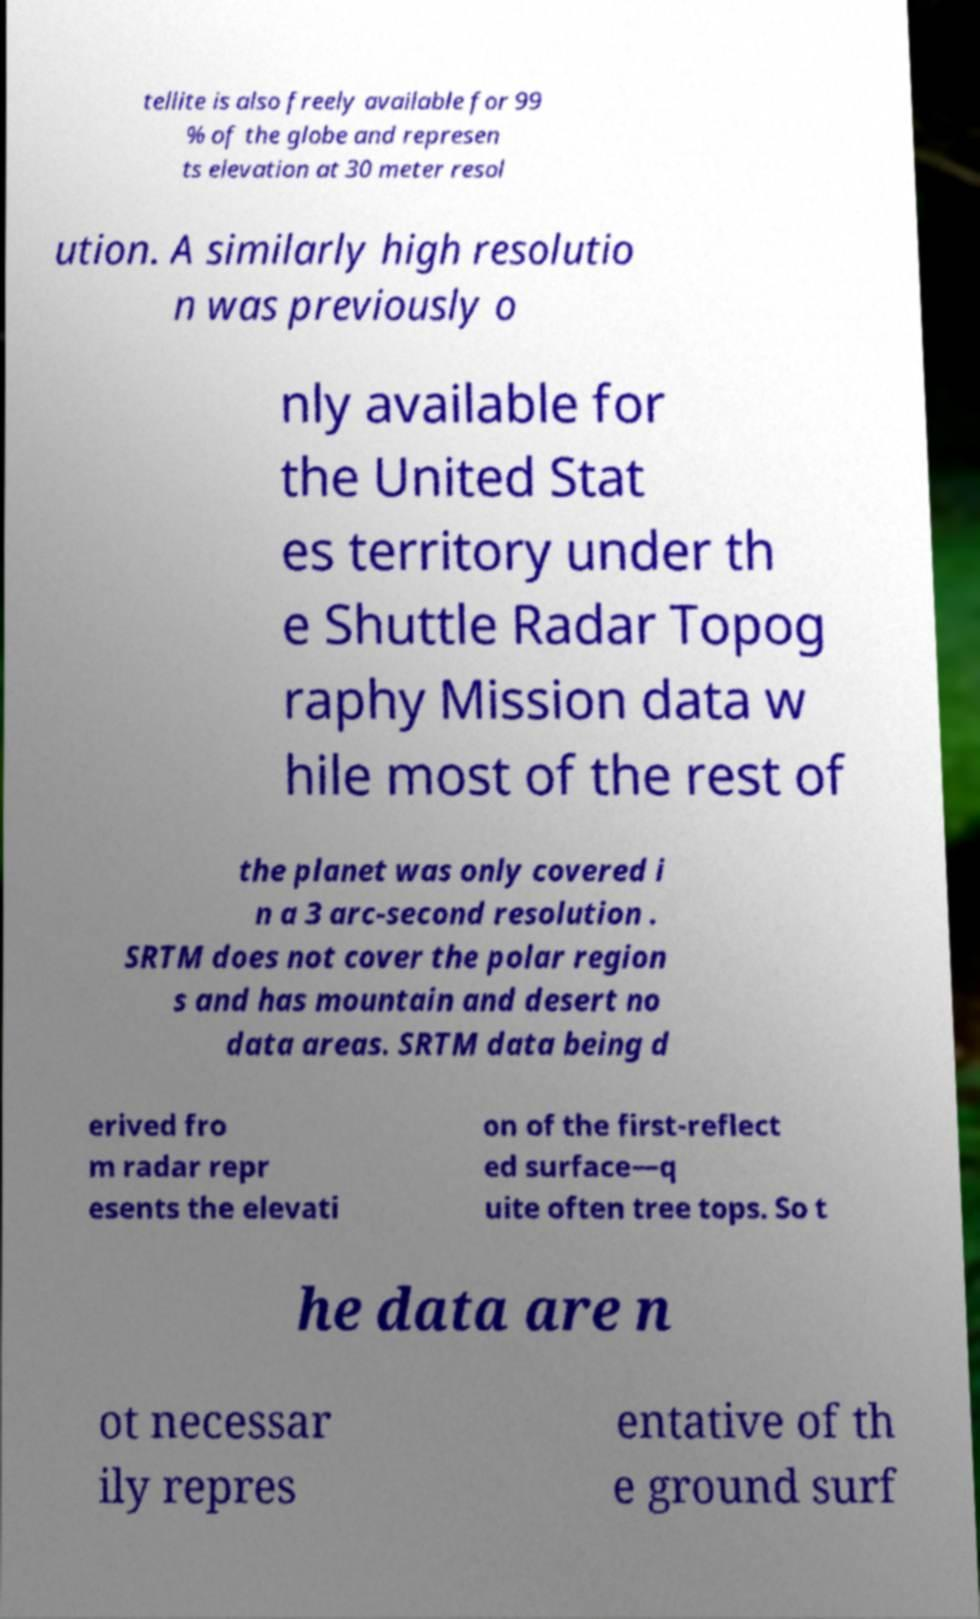Could you assist in decoding the text presented in this image and type it out clearly? tellite is also freely available for 99 % of the globe and represen ts elevation at 30 meter resol ution. A similarly high resolutio n was previously o nly available for the United Stat es territory under th e Shuttle Radar Topog raphy Mission data w hile most of the rest of the planet was only covered i n a 3 arc-second resolution . SRTM does not cover the polar region s and has mountain and desert no data areas. SRTM data being d erived fro m radar repr esents the elevati on of the first-reflect ed surface—q uite often tree tops. So t he data are n ot necessar ily repres entative of th e ground surf 